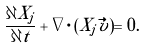Convert formula to latex. <formula><loc_0><loc_0><loc_500><loc_500>\frac { \partial X _ { j } } { \partial t } + \nabla \cdot ( X _ { j } \vec { v } ) = 0 .</formula> 